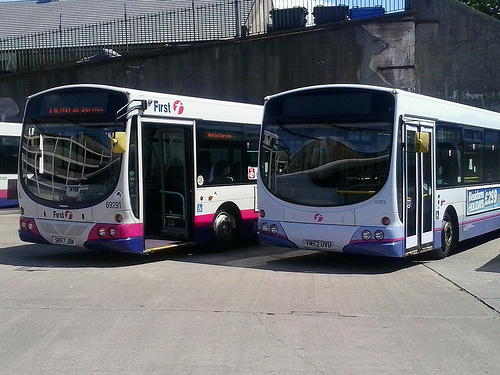How many buses are the doors open? There is one bus with its doors open, visible on the bus to the right of the image. The other bus depicted does not have its doors open. 